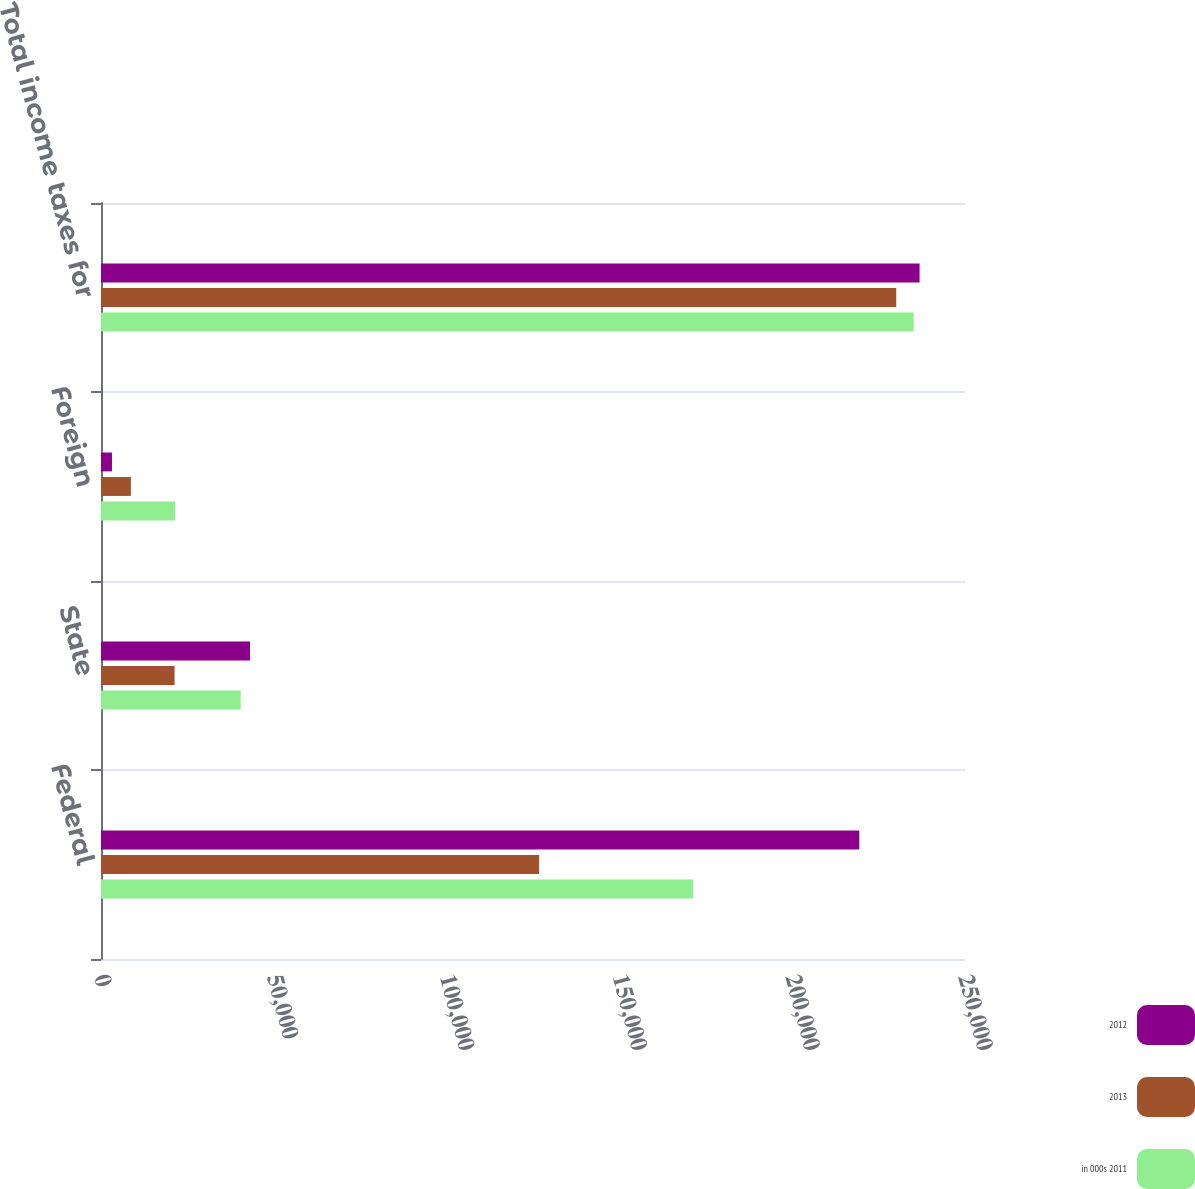Convert chart. <chart><loc_0><loc_0><loc_500><loc_500><stacked_bar_chart><ecel><fcel>Federal<fcel>State<fcel>Foreign<fcel>Total income taxes for<nl><fcel>2012<fcel>219411<fcel>43116<fcel>3173<fcel>236853<nl><fcel>2013<fcel>126773<fcel>21285<fcel>8647<fcel>230102<nl><fcel>in 000s 2011<fcel>171337<fcel>40433<fcel>21456<fcel>235156<nl></chart> 